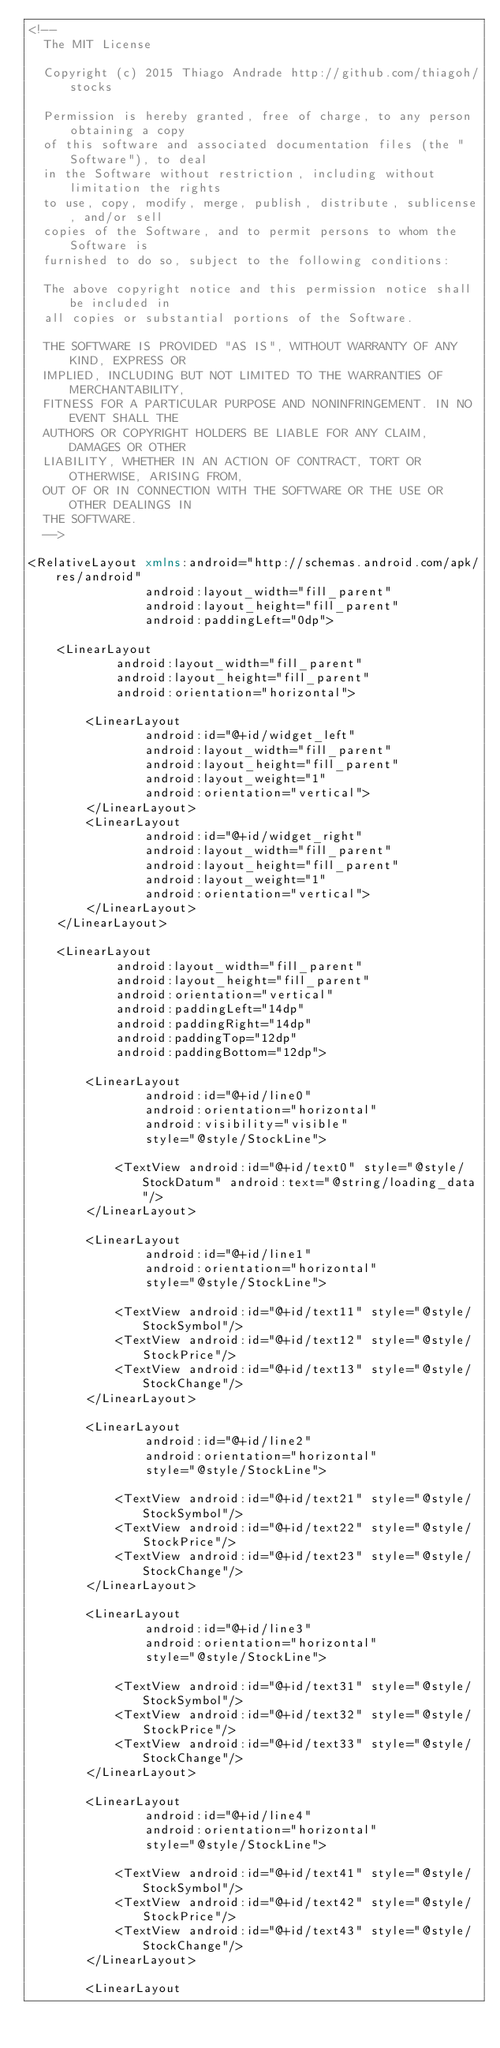Convert code to text. <code><loc_0><loc_0><loc_500><loc_500><_XML_><!--
  The MIT License

  Copyright (c) 2015 Thiago Andrade http://github.com/thiagoh/stocks

  Permission is hereby granted, free of charge, to any person obtaining a copy
  of this software and associated documentation files (the "Software"), to deal
  in the Software without restriction, including without limitation the rights
  to use, copy, modify, merge, publish, distribute, sublicense, and/or sell
  copies of the Software, and to permit persons to whom the Software is
  furnished to do so, subject to the following conditions:

  The above copyright notice and this permission notice shall be included in
  all copies or substantial portions of the Software.

  THE SOFTWARE IS PROVIDED "AS IS", WITHOUT WARRANTY OF ANY KIND, EXPRESS OR
  IMPLIED, INCLUDING BUT NOT LIMITED TO THE WARRANTIES OF MERCHANTABILITY,
  FITNESS FOR A PARTICULAR PURPOSE AND NONINFRINGEMENT. IN NO EVENT SHALL THE
  AUTHORS OR COPYRIGHT HOLDERS BE LIABLE FOR ANY CLAIM, DAMAGES OR OTHER
  LIABILITY, WHETHER IN AN ACTION OF CONTRACT, TORT OR OTHERWISE, ARISING FROM,
  OUT OF OR IN CONNECTION WITH THE SOFTWARE OR THE USE OR OTHER DEALINGS IN
  THE SOFTWARE.
  -->

<RelativeLayout xmlns:android="http://schemas.android.com/apk/res/android"
                android:layout_width="fill_parent"
                android:layout_height="fill_parent"
                android:paddingLeft="0dp">

    <LinearLayout
            android:layout_width="fill_parent"
            android:layout_height="fill_parent"
            android:orientation="horizontal">

        <LinearLayout
                android:id="@+id/widget_left"
                android:layout_width="fill_parent"
                android:layout_height="fill_parent"
                android:layout_weight="1"
                android:orientation="vertical">
        </LinearLayout>
        <LinearLayout
                android:id="@+id/widget_right"
                android:layout_width="fill_parent"
                android:layout_height="fill_parent"
                android:layout_weight="1"
                android:orientation="vertical">
        </LinearLayout>
    </LinearLayout>

    <LinearLayout
            android:layout_width="fill_parent"
            android:layout_height="fill_parent"
            android:orientation="vertical"
            android:paddingLeft="14dp"
            android:paddingRight="14dp"
            android:paddingTop="12dp"
            android:paddingBottom="12dp">

        <LinearLayout
                android:id="@+id/line0"
                android:orientation="horizontal"
                android:visibility="visible"
                style="@style/StockLine">

            <TextView android:id="@+id/text0" style="@style/StockDatum" android:text="@string/loading_data"/>
        </LinearLayout>

        <LinearLayout
                android:id="@+id/line1"
                android:orientation="horizontal"
                style="@style/StockLine">

            <TextView android:id="@+id/text11" style="@style/StockSymbol"/>
            <TextView android:id="@+id/text12" style="@style/StockPrice"/>
            <TextView android:id="@+id/text13" style="@style/StockChange"/>
        </LinearLayout>

        <LinearLayout
                android:id="@+id/line2"
                android:orientation="horizontal"
                style="@style/StockLine">

            <TextView android:id="@+id/text21" style="@style/StockSymbol"/>
            <TextView android:id="@+id/text22" style="@style/StockPrice"/>
            <TextView android:id="@+id/text23" style="@style/StockChange"/>
        </LinearLayout>

        <LinearLayout
                android:id="@+id/line3"
                android:orientation="horizontal"
                style="@style/StockLine">

            <TextView android:id="@+id/text31" style="@style/StockSymbol"/>
            <TextView android:id="@+id/text32" style="@style/StockPrice"/>
            <TextView android:id="@+id/text33" style="@style/StockChange"/>
        </LinearLayout>

        <LinearLayout
                android:id="@+id/line4"
                android:orientation="horizontal"
                style="@style/StockLine">

            <TextView android:id="@+id/text41" style="@style/StockSymbol"/>
            <TextView android:id="@+id/text42" style="@style/StockPrice"/>
            <TextView android:id="@+id/text43" style="@style/StockChange"/>
        </LinearLayout>

        <LinearLayout</code> 